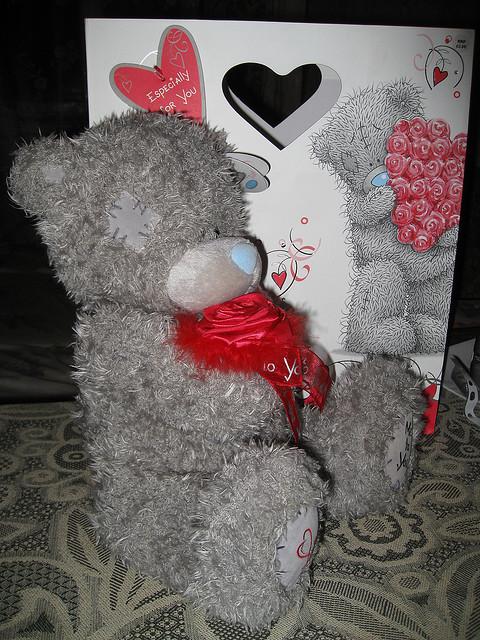What color is the teddy bear?
Be succinct. Gray. What color is the bear?
Answer briefly. Gray. What shape is the ribbon around the bears neck?
Concise answer only. Rose. What is the bear holding?
Give a very brief answer. Rose. What is the teddy bear holding?
Quick response, please. Rose. What holiday are these gifts for?
Write a very short answer. Valentine's day. Is the teddy bear white?
Write a very short answer. No. 